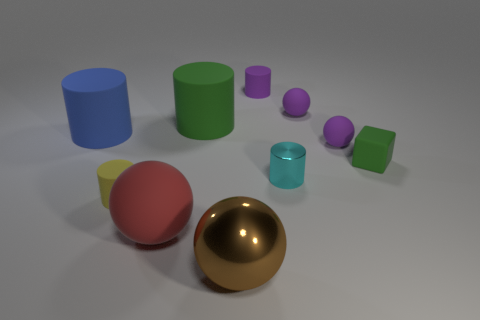Is there any other thing that is the same shape as the big red rubber thing? Yes, there is a smaller purple item of the same spherical shape as the large red rubber object, indicating that these objects share geometrical similarity. 